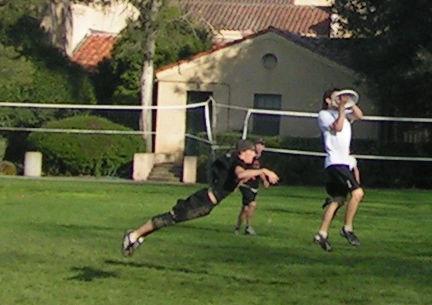How many people are there?
Give a very brief answer. 2. 